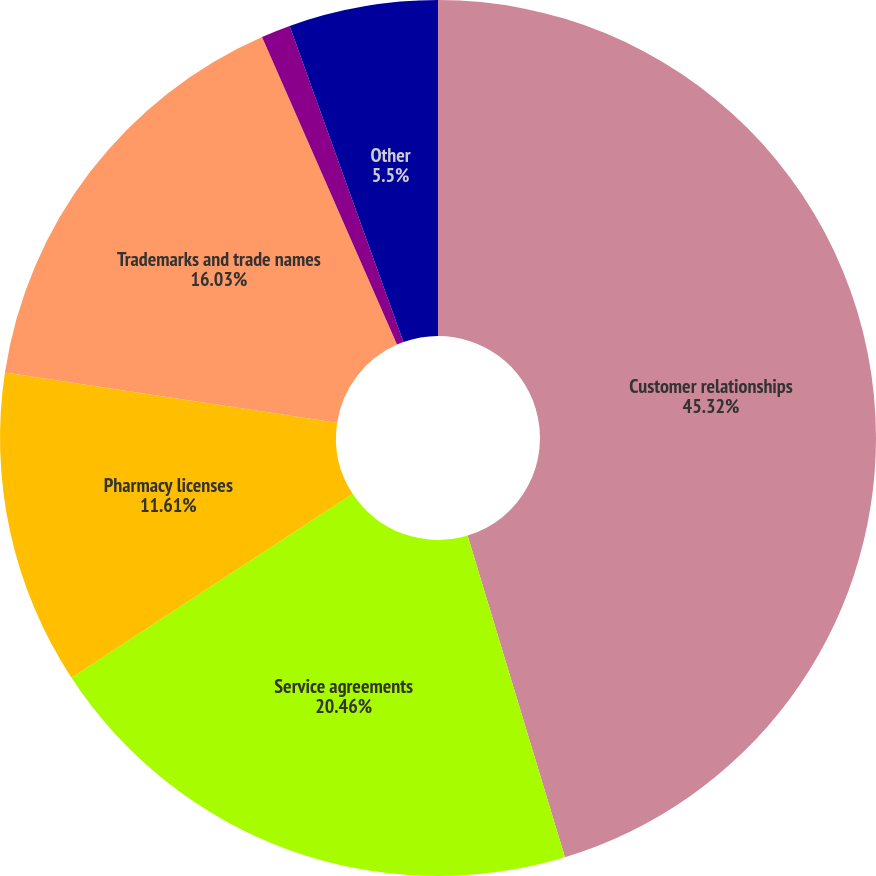Convert chart. <chart><loc_0><loc_0><loc_500><loc_500><pie_chart><fcel>Customer relationships<fcel>Service agreements<fcel>Pharmacy licenses<fcel>Trademarks and trade names<fcel>Technology<fcel>Other<nl><fcel>45.32%<fcel>20.46%<fcel>11.61%<fcel>16.03%<fcel>1.08%<fcel>5.5%<nl></chart> 